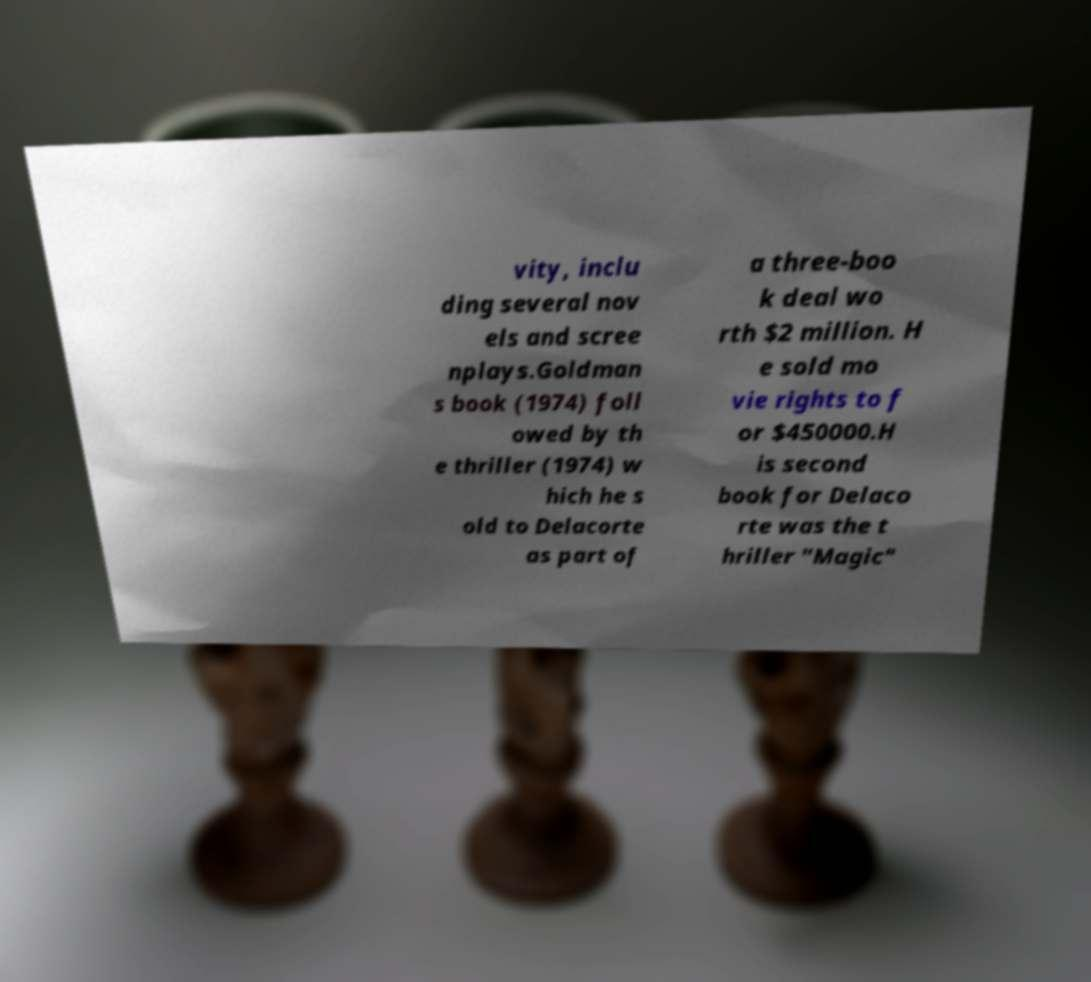For documentation purposes, I need the text within this image transcribed. Could you provide that? vity, inclu ding several nov els and scree nplays.Goldman s book (1974) foll owed by th e thriller (1974) w hich he s old to Delacorte as part of a three-boo k deal wo rth $2 million. H e sold mo vie rights to f or $450000.H is second book for Delaco rte was the t hriller "Magic" 